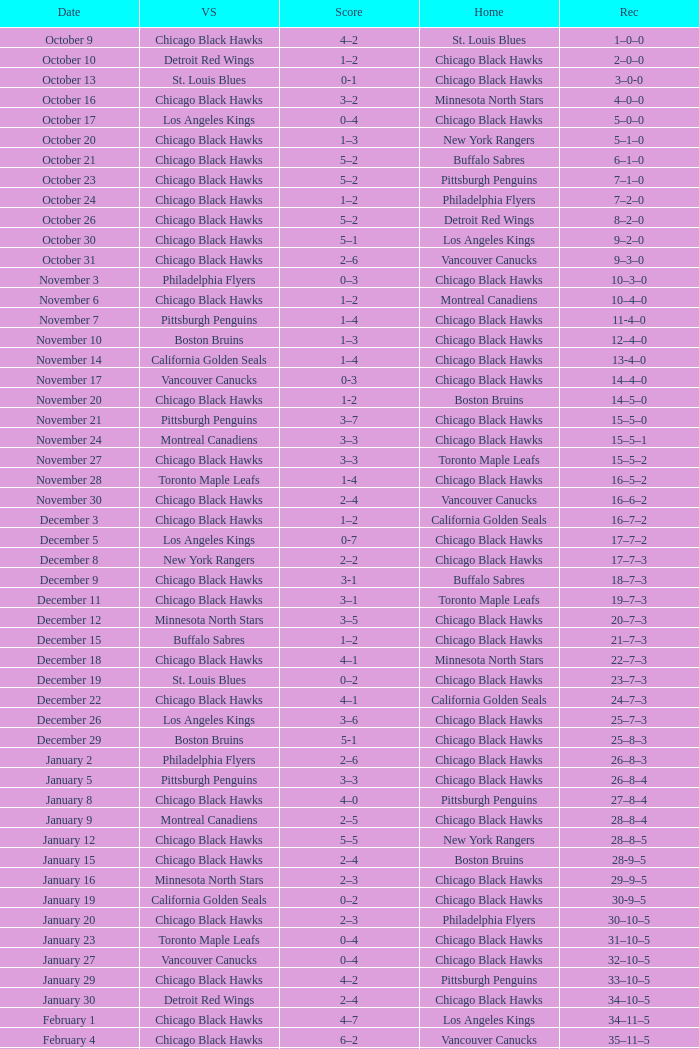What is the Score of the Chicago Black Hawks Home game with the Visiting Vancouver Canucks on November 17? 0-3. 